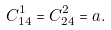Convert formula to latex. <formula><loc_0><loc_0><loc_500><loc_500>C _ { 1 4 } ^ { 1 } = C _ { 2 4 } ^ { 2 } = a .</formula> 